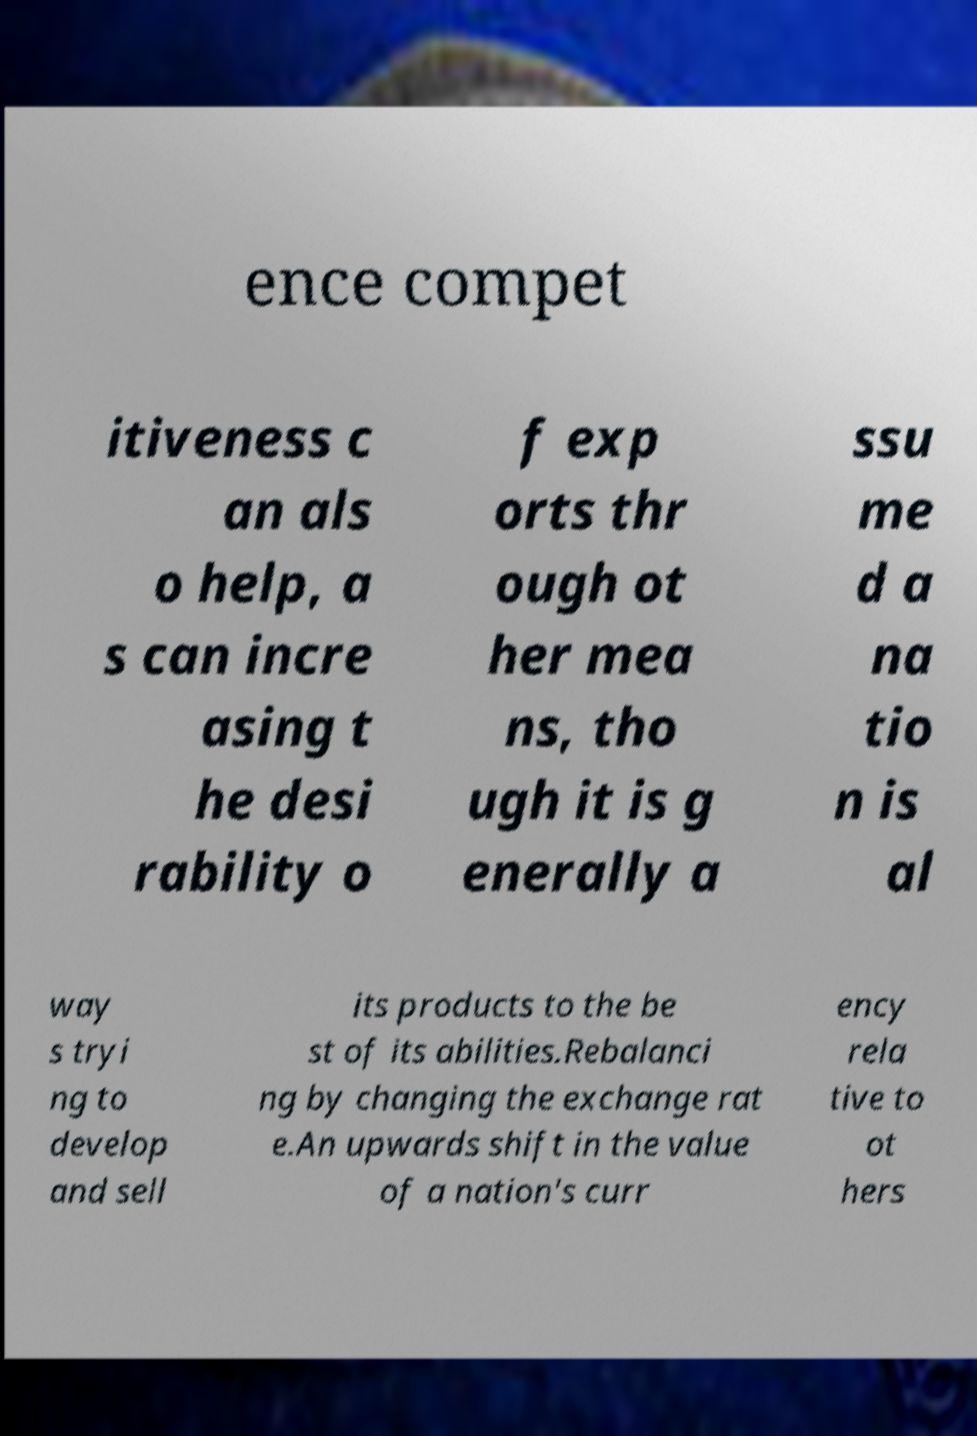Please identify and transcribe the text found in this image. ence compet itiveness c an als o help, a s can incre asing t he desi rability o f exp orts thr ough ot her mea ns, tho ugh it is g enerally a ssu me d a na tio n is al way s tryi ng to develop and sell its products to the be st of its abilities.Rebalanci ng by changing the exchange rat e.An upwards shift in the value of a nation's curr ency rela tive to ot hers 